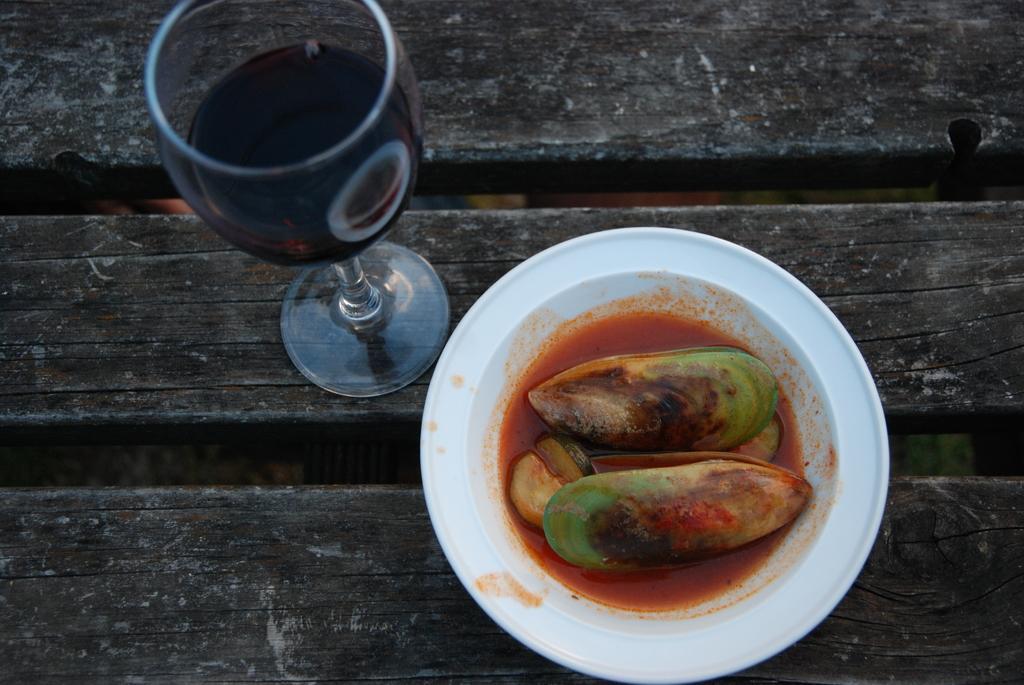Could you give a brief overview of what you see in this image? In this image we can see food in the serving plate and beverage in the tumbler are placed on the wooden surface. 